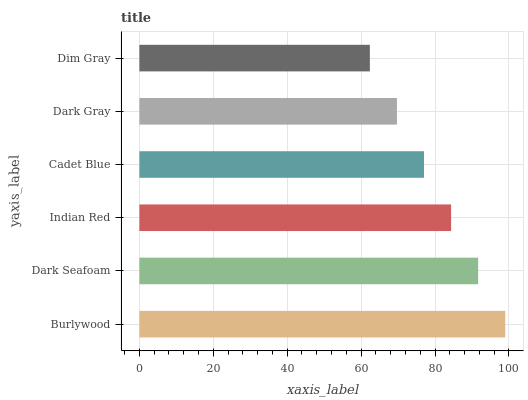Is Dim Gray the minimum?
Answer yes or no. Yes. Is Burlywood the maximum?
Answer yes or no. Yes. Is Dark Seafoam the minimum?
Answer yes or no. No. Is Dark Seafoam the maximum?
Answer yes or no. No. Is Burlywood greater than Dark Seafoam?
Answer yes or no. Yes. Is Dark Seafoam less than Burlywood?
Answer yes or no. Yes. Is Dark Seafoam greater than Burlywood?
Answer yes or no. No. Is Burlywood less than Dark Seafoam?
Answer yes or no. No. Is Indian Red the high median?
Answer yes or no. Yes. Is Cadet Blue the low median?
Answer yes or no. Yes. Is Dark Gray the high median?
Answer yes or no. No. Is Dim Gray the low median?
Answer yes or no. No. 